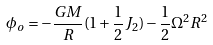<formula> <loc_0><loc_0><loc_500><loc_500>\phi _ { o } = - \frac { G M } { R } ( 1 + \frac { 1 } { 2 } J _ { 2 } ) - \frac { 1 } { 2 } \Omega ^ { 2 } R ^ { 2 }</formula> 